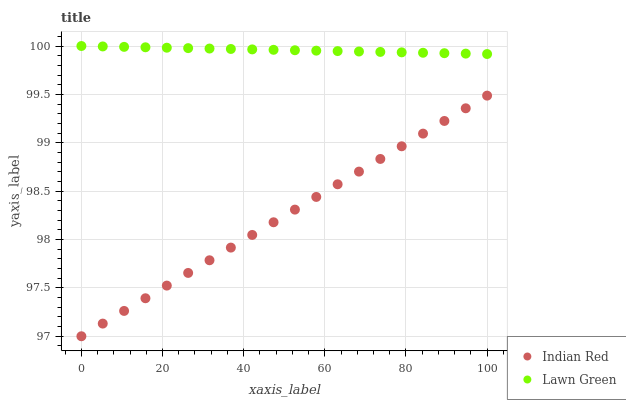Does Indian Red have the minimum area under the curve?
Answer yes or no. Yes. Does Lawn Green have the maximum area under the curve?
Answer yes or no. Yes. Does Indian Red have the maximum area under the curve?
Answer yes or no. No. Is Indian Red the smoothest?
Answer yes or no. Yes. Is Lawn Green the roughest?
Answer yes or no. Yes. Is Indian Red the roughest?
Answer yes or no. No. Does Indian Red have the lowest value?
Answer yes or no. Yes. Does Lawn Green have the highest value?
Answer yes or no. Yes. Does Indian Red have the highest value?
Answer yes or no. No. Is Indian Red less than Lawn Green?
Answer yes or no. Yes. Is Lawn Green greater than Indian Red?
Answer yes or no. Yes. Does Indian Red intersect Lawn Green?
Answer yes or no. No. 